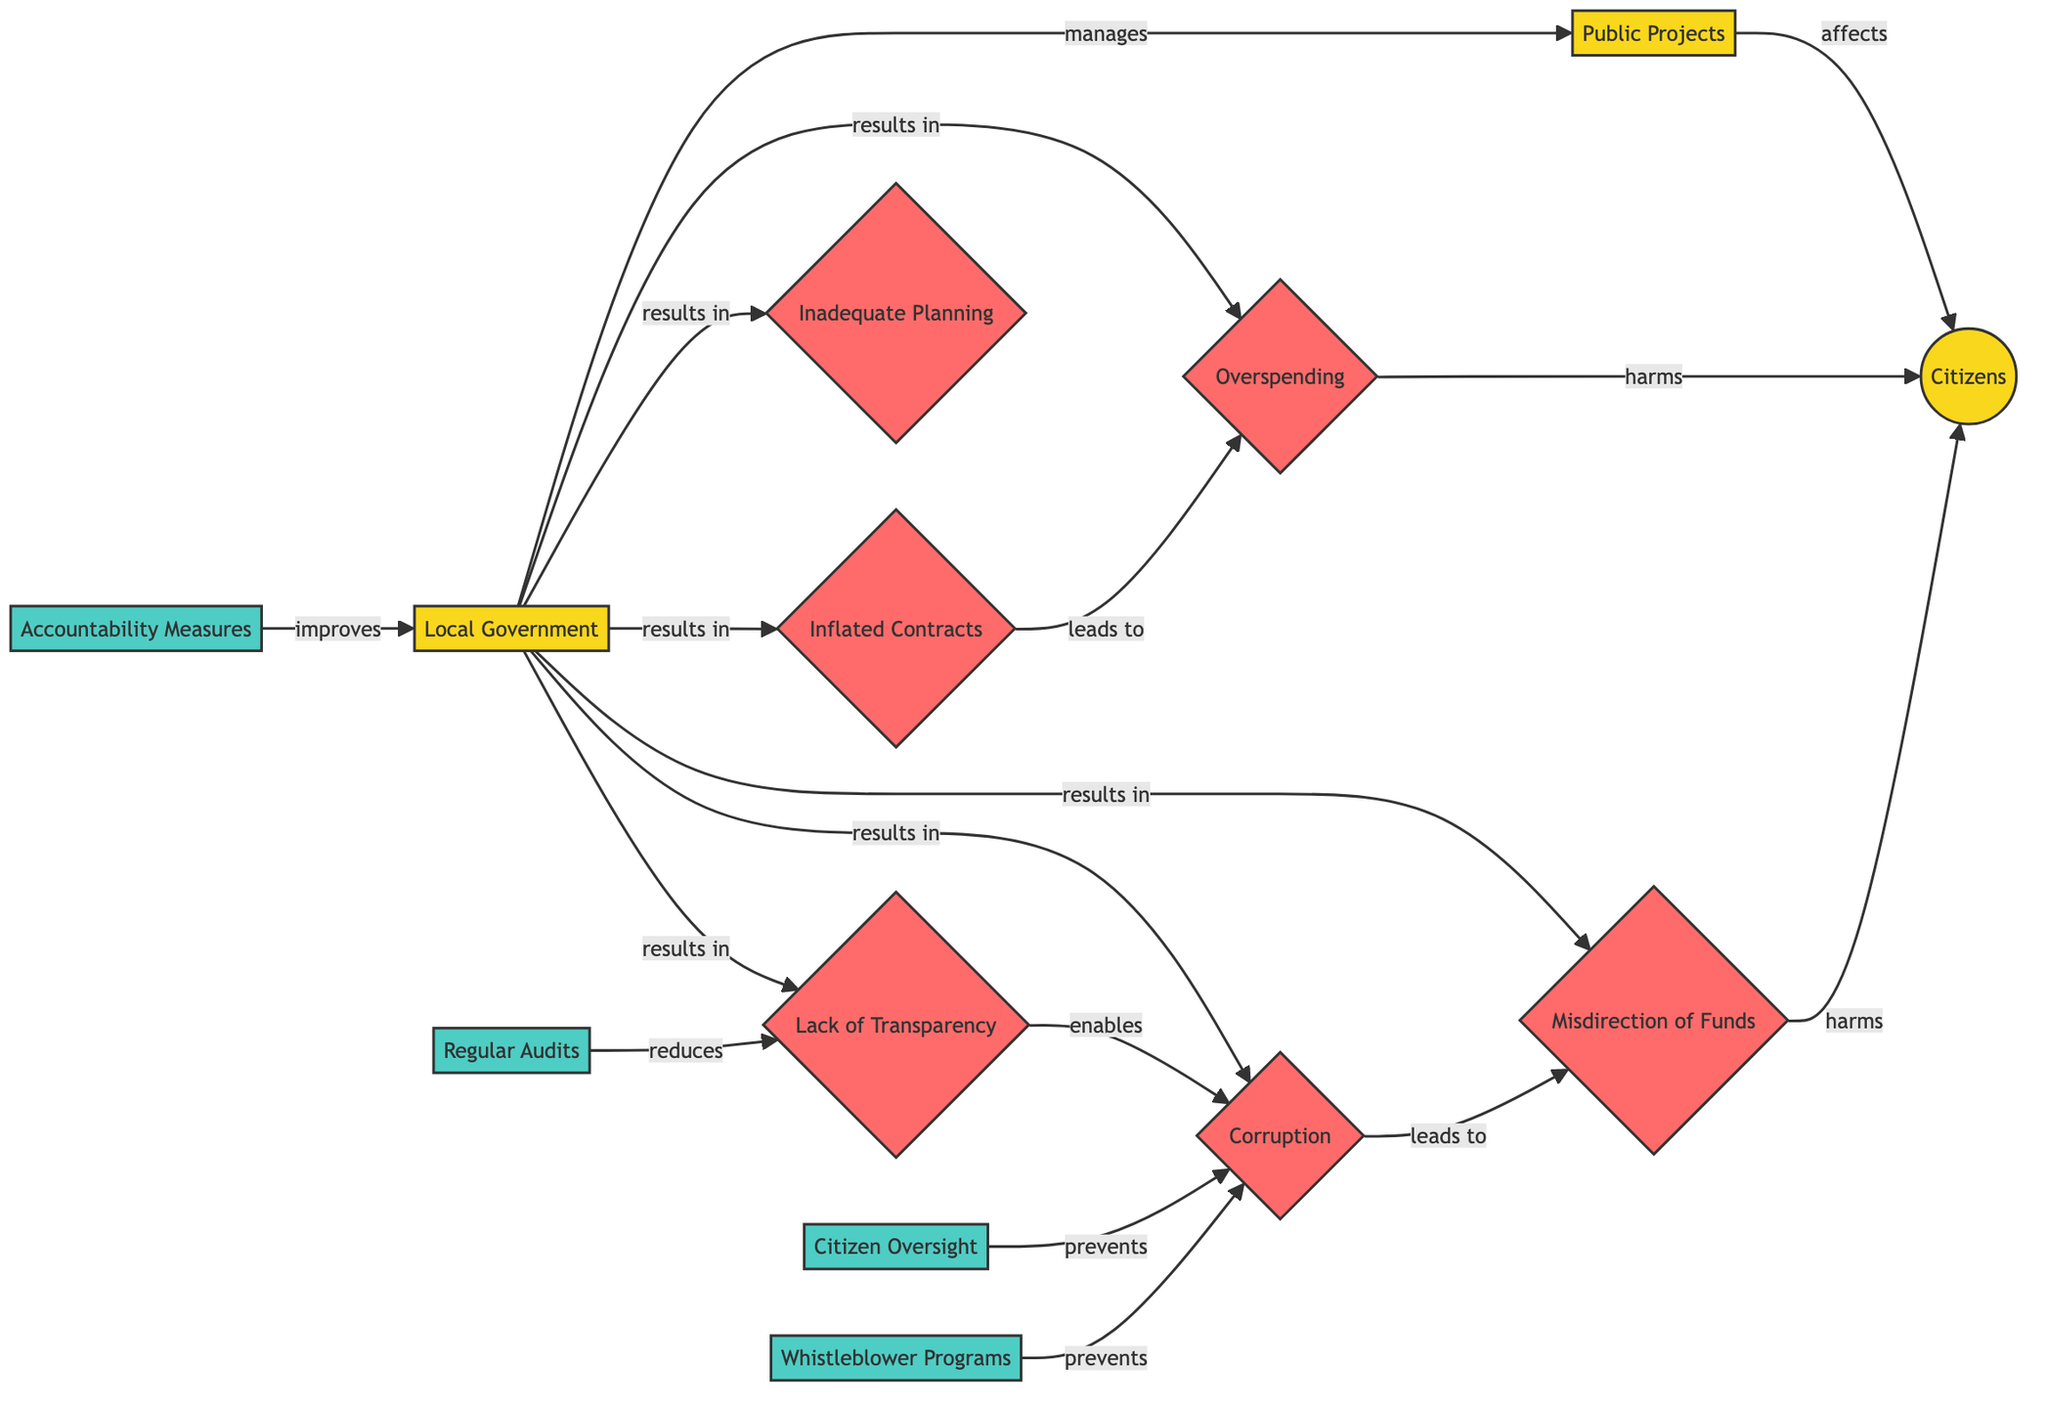What is the total number of nodes in the diagram? There are 13 nodes in the diagram: Citizens, Local Government, Public Projects, Inflated Contracts, Corruption, Lack of Transparency, Misdirection of Funds, Overspending, Inadequate Planning, Accountability Measures, Regular Audits, Citizen Oversight, and Whistleblower Programs.
Answer: 13 What relationship exists between Local Government and Public Projects? The Local Government manages the Public Projects, as indicated by the directed edge showing the relationship.
Answer: manages Which issue is directly affected by Overspending? Citizens are harmed by Overspending, as shown by the directed edge leading from Overspending to Citizens with a "harms" relation.
Answer: Citizens How many solutions are proposed in the diagram? There are four solutions proposed in the diagram: Accountability Measures, Regular Audits, Citizen Oversight, and Whistleblower Programs.
Answer: 4 What does the Lack of Transparency enable? The Lack of Transparency enables Corruption, as indicated by the directed edge that connects Lack of Transparency to Corruption with an "enables" relation.
Answer: Corruption Which issue leads to Misdirection of Funds? Corruption leads to Misdirection of Funds, as shown by the directed edge indicating a causal relationship between them.
Answer: Corruption What type of relationship exists between Accountability Measures and Local Government? Accountability Measures have an "improves" relationship with the Local Government, indicating that they enhance its performance.
Answer: improves If Local Government is responsible for Overspending, what other issues does it directly result in? Local Government results in several issues, specifically Inflated Contracts, Corruption, Lack of Transparency, Misdirection of Funds, and Inadequate Planning. Each of these issues is linked through directed edges showing the causal relationship.
Answer: Inflated Contracts, Corruption, Lack of Transparency, Misdirection of Funds, Inadequate Planning What solution prevents corruption according to the diagram? Both Citizen Oversight and Whistleblower Programs are noted in the diagram as solutions that prevent Corruption, as indicated by the directed edges leading to Corruption.
Answer: Citizen Oversight, Whistleblower Programs 